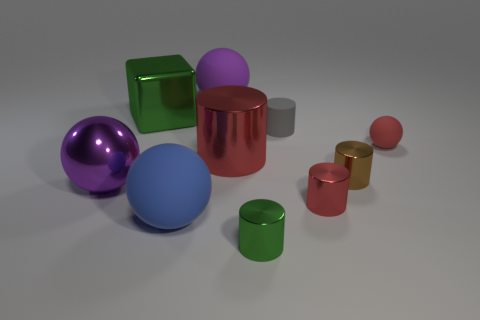Subtract all gray cylinders. How many cylinders are left? 4 Subtract all tiny brown shiny cylinders. How many cylinders are left? 4 Subtract 1 spheres. How many spheres are left? 3 Subtract all yellow spheres. Subtract all red cubes. How many spheres are left? 4 Subtract all spheres. How many objects are left? 6 Add 9 blue metal balls. How many blue metal balls exist? 9 Subtract 1 red balls. How many objects are left? 9 Subtract all red things. Subtract all tiny gray rubber cylinders. How many objects are left? 6 Add 8 gray rubber objects. How many gray rubber objects are left? 9 